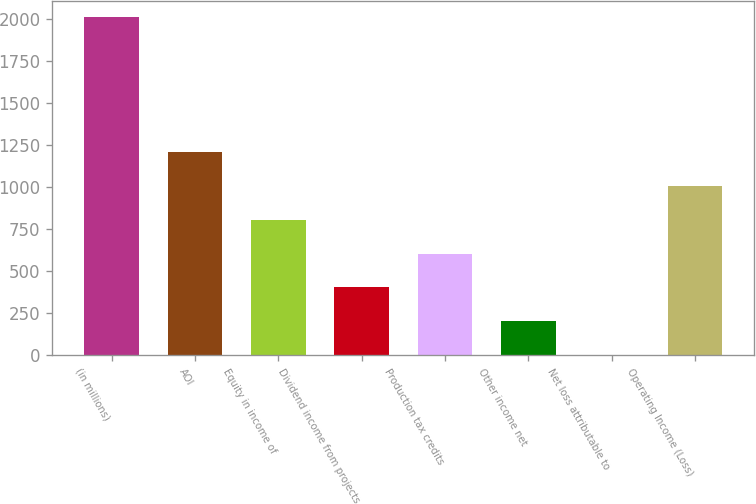Convert chart to OTSL. <chart><loc_0><loc_0><loc_500><loc_500><bar_chart><fcel>(in millions)<fcel>AOI<fcel>Equity in income of<fcel>Dividend income from projects<fcel>Production tax credits<fcel>Other income net<fcel>Net loss attributable to<fcel>Operating Income (Loss)<nl><fcel>2010<fcel>1206.4<fcel>804.6<fcel>402.8<fcel>603.7<fcel>201.9<fcel>1<fcel>1005.5<nl></chart> 